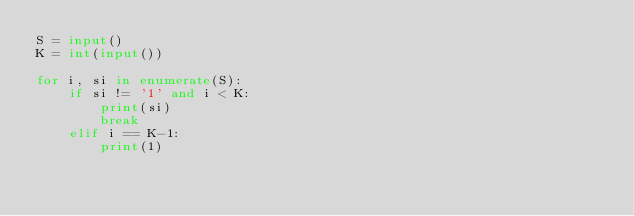Convert code to text. <code><loc_0><loc_0><loc_500><loc_500><_Python_>S = input()
K = int(input())

for i, si in enumerate(S):
    if si != '1' and i < K:
        print(si)
        break
    elif i == K-1:
        print(1)</code> 